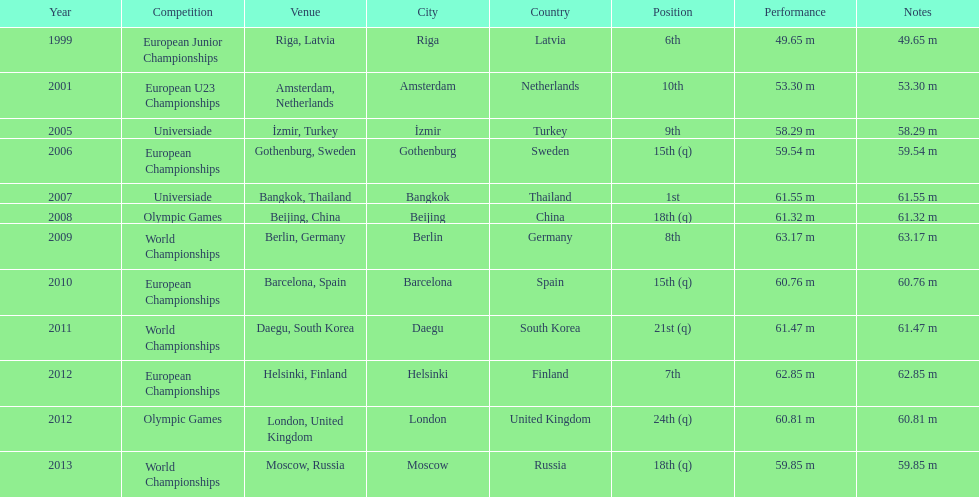How many world championships has he been in? 3. 